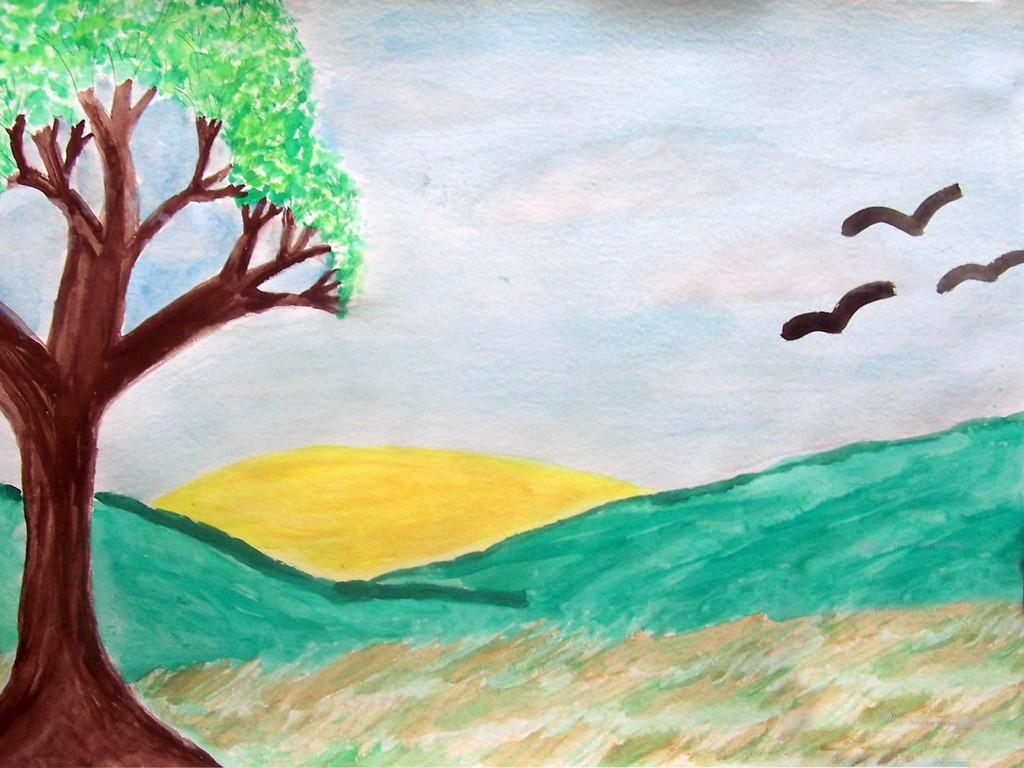What type of art is depicted in the image? There is an art of birds in the image. What other elements can be seen in the image besides the art? There are trees in the image. How would you describe the sky in the background of the image? The sky in the background is a combination of white and blue colors. What type of wood is used to create the house in the image? There is no house present in the image; it features an art of birds and trees with a background sky. 